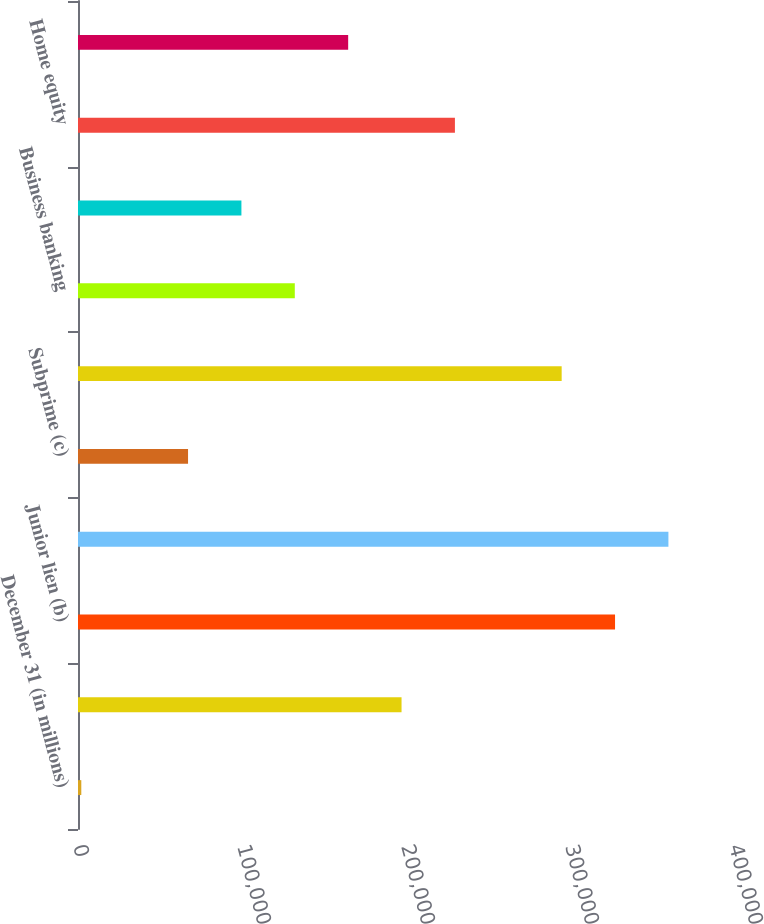Convert chart. <chart><loc_0><loc_0><loc_500><loc_500><bar_chart><fcel>December 31 (in millions)<fcel>Senior lien (a)<fcel>Junior lien (b)<fcel>Prime including option ARMs<fcel>Subprime (c)<fcel>Auto (c)<fcel>Business banking<fcel>Student and other (c)<fcel>Home equity<fcel>Prime mortgage<nl><fcel>2010<fcel>197282<fcel>327464<fcel>360009<fcel>67100.8<fcel>294919<fcel>132192<fcel>99646.2<fcel>229828<fcel>164737<nl></chart> 